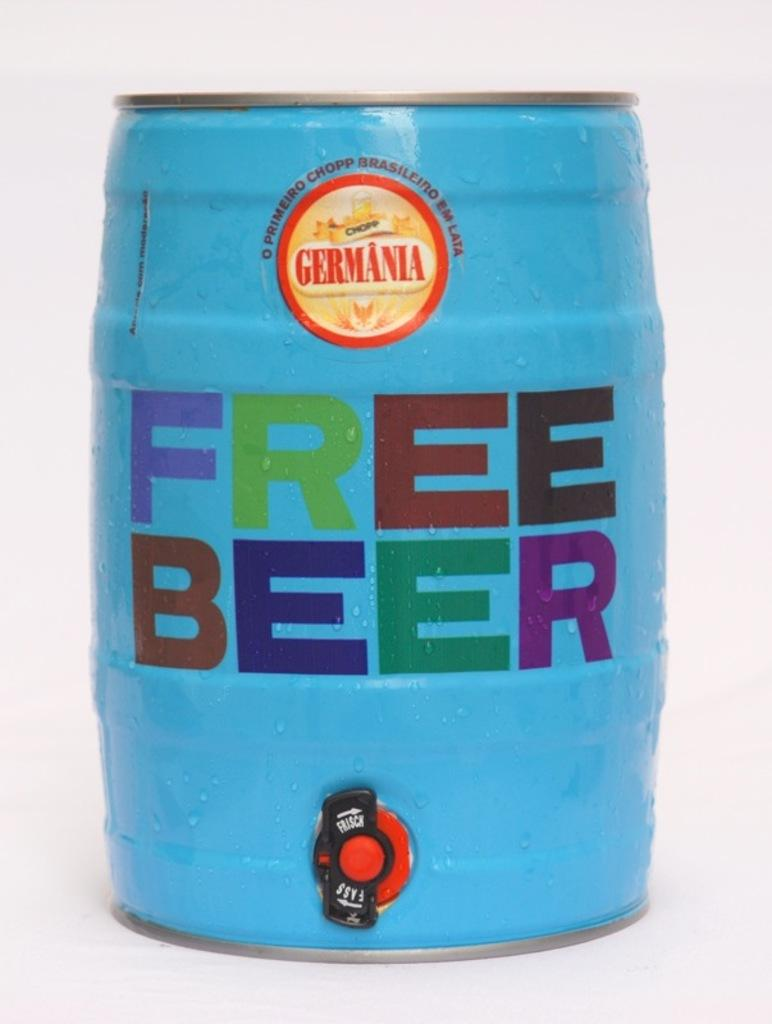<image>
Relay a brief, clear account of the picture shown. A blue keg with the text free beer on the middle in bold font. 